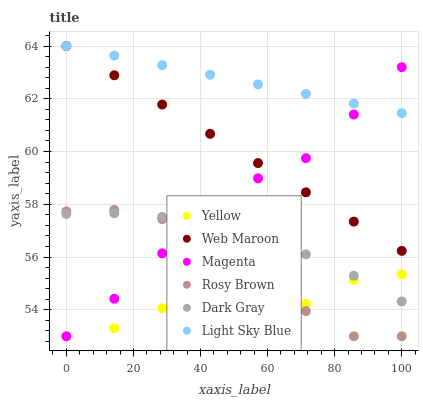Does Yellow have the minimum area under the curve?
Answer yes or no. Yes. Does Light Sky Blue have the maximum area under the curve?
Answer yes or no. Yes. Does Web Maroon have the minimum area under the curve?
Answer yes or no. No. Does Web Maroon have the maximum area under the curve?
Answer yes or no. No. Is Light Sky Blue the smoothest?
Answer yes or no. Yes. Is Rosy Brown the roughest?
Answer yes or no. Yes. Is Web Maroon the smoothest?
Answer yes or no. No. Is Web Maroon the roughest?
Answer yes or no. No. Does Rosy Brown have the lowest value?
Answer yes or no. Yes. Does Web Maroon have the lowest value?
Answer yes or no. No. Does Light Sky Blue have the highest value?
Answer yes or no. Yes. Does Yellow have the highest value?
Answer yes or no. No. Is Yellow less than Light Sky Blue?
Answer yes or no. Yes. Is Light Sky Blue greater than Dark Gray?
Answer yes or no. Yes. Does Web Maroon intersect Magenta?
Answer yes or no. Yes. Is Web Maroon less than Magenta?
Answer yes or no. No. Is Web Maroon greater than Magenta?
Answer yes or no. No. Does Yellow intersect Light Sky Blue?
Answer yes or no. No. 